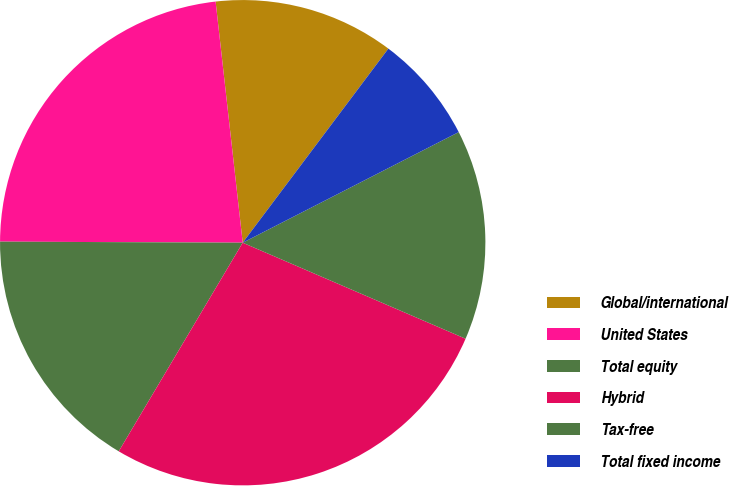<chart> <loc_0><loc_0><loc_500><loc_500><pie_chart><fcel>Global/international<fcel>United States<fcel>Total equity<fcel>Hybrid<fcel>Tax-free<fcel>Total fixed income<nl><fcel>12.03%<fcel>23.15%<fcel>16.54%<fcel>27.06%<fcel>14.01%<fcel>7.22%<nl></chart> 